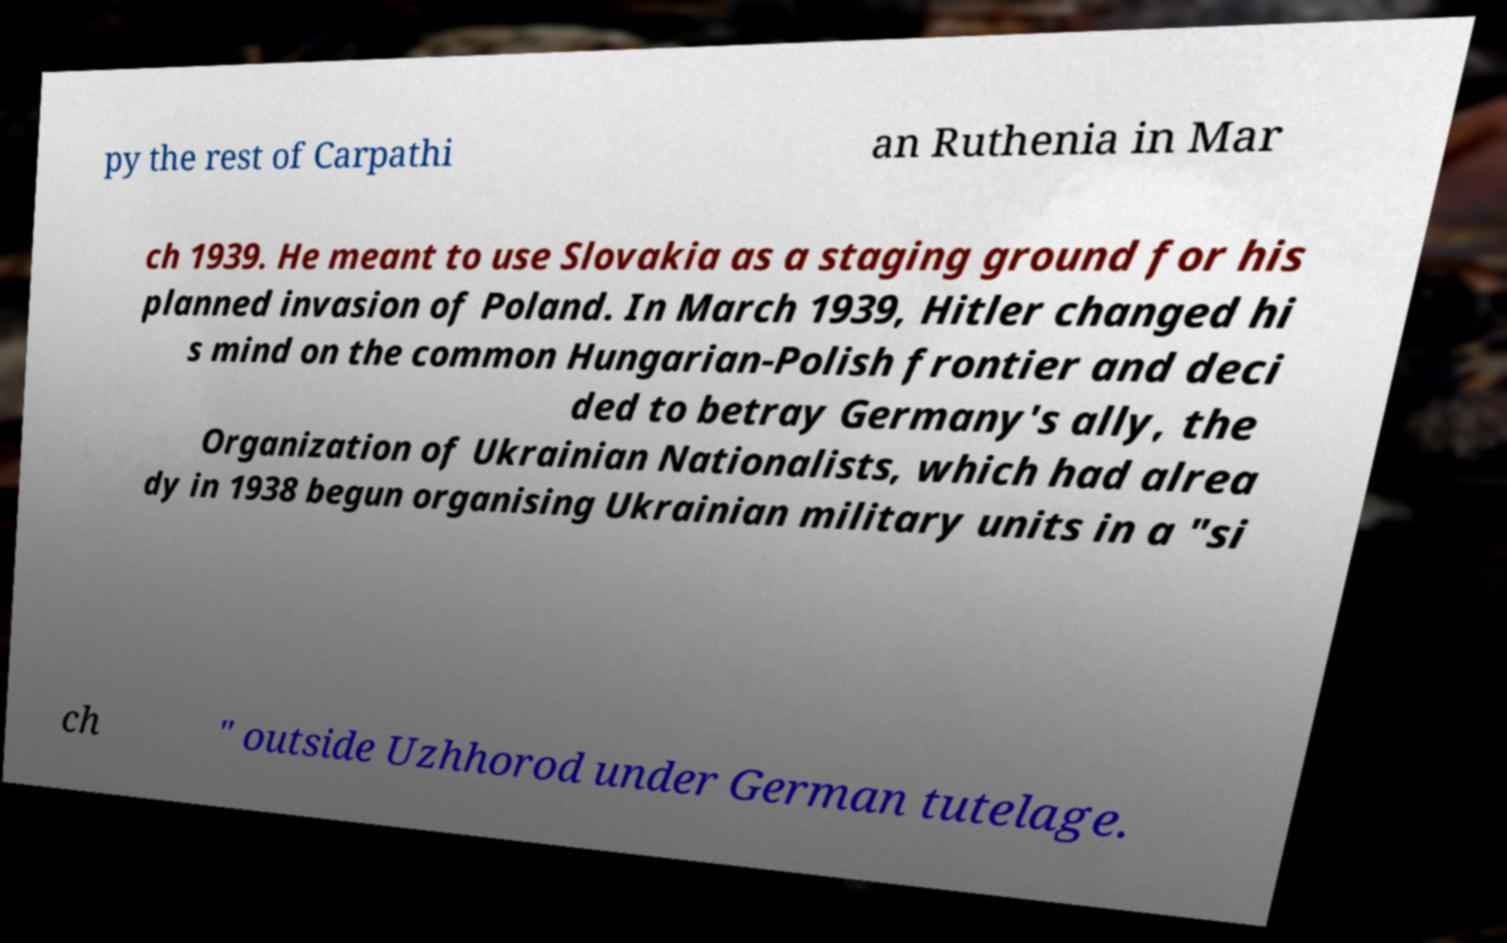Please identify and transcribe the text found in this image. py the rest of Carpathi an Ruthenia in Mar ch 1939. He meant to use Slovakia as a staging ground for his planned invasion of Poland. In March 1939, Hitler changed hi s mind on the common Hungarian-Polish frontier and deci ded to betray Germany's ally, the Organization of Ukrainian Nationalists, which had alrea dy in 1938 begun organising Ukrainian military units in a "si ch " outside Uzhhorod under German tutelage. 